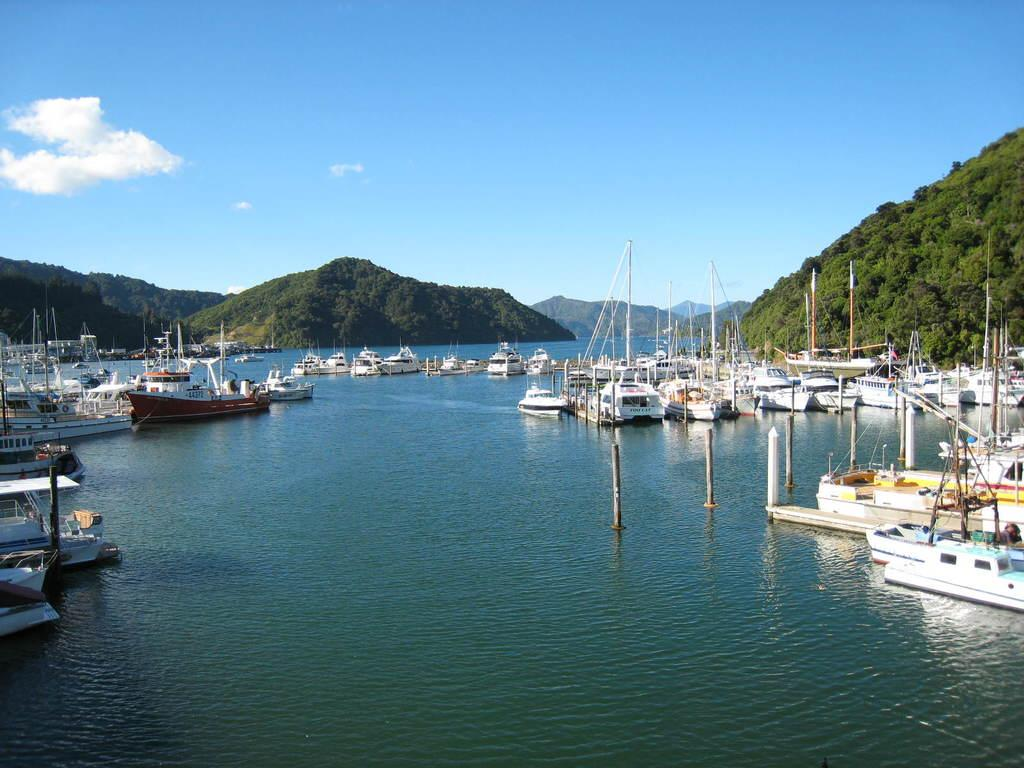What type of vehicles can be seen in the water in the image? There are ships in the water in the image. What type of landform can be seen in the image? There are hills visible in the image. What is the condition of the sky in the image? The sky is clouded in the image. What type of insurance is required for the ships in the image? There is no information about insurance in the image, as it only shows ships in the water, hills, and a clouded sky. 